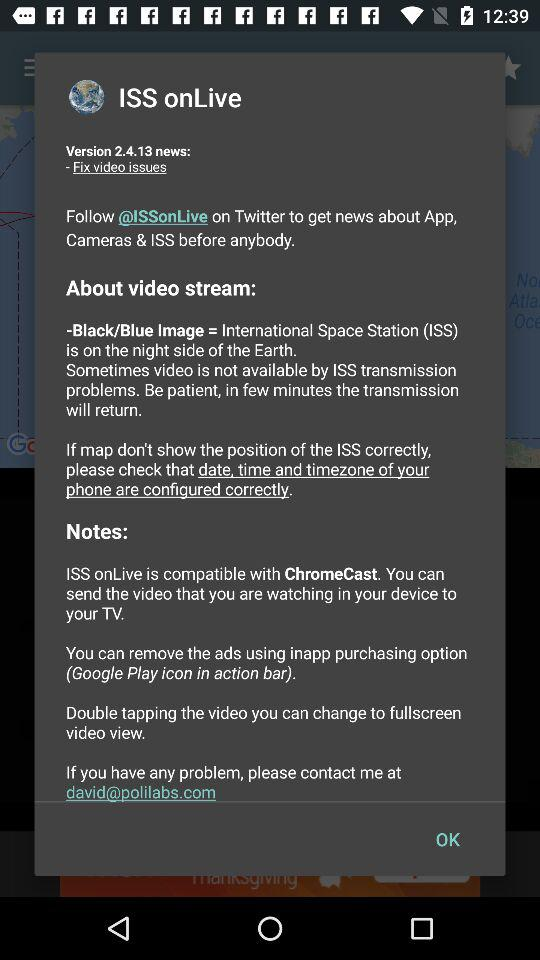What is the name of the application? The name of the application is "ISS onLive". 